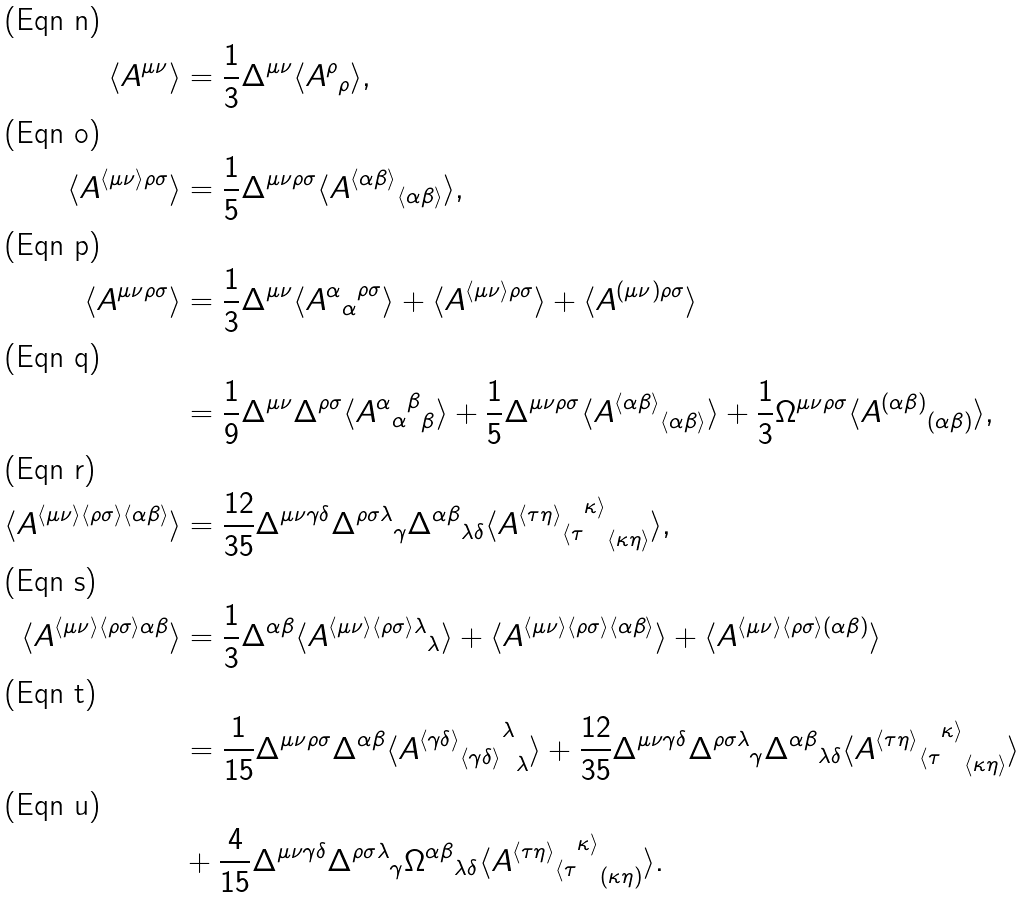Convert formula to latex. <formula><loc_0><loc_0><loc_500><loc_500>\langle A ^ { \mu \nu } \rangle & = \frac { 1 } { 3 } \Delta ^ { \mu \nu } \langle { A ^ { \rho } } _ { \rho } \rangle , \\ \langle A ^ { \langle \mu \nu \rangle \rho \sigma } \rangle & = \frac { 1 } { 5 } \Delta ^ { \mu \nu \rho \sigma } \langle { A ^ { \langle \alpha \beta \rangle } } _ { \langle \alpha \beta \rangle } \rangle , \\ \langle A ^ { \mu \nu \rho \sigma } \rangle & = \frac { 1 } { 3 } \Delta ^ { \mu \nu } \langle { { A ^ { \alpha } } _ { \alpha } } ^ { \rho \sigma } \rangle + \langle A ^ { \langle \mu \nu \rangle \rho \sigma } \rangle + \langle A ^ { ( \mu \nu ) \rho \sigma } \rangle \\ & = \frac { 1 } { 9 } \Delta ^ { \mu \nu } \Delta ^ { \rho \sigma } \langle { { { A ^ { \alpha } } _ { \alpha } } ^ { \beta } } _ { \beta } \rangle + \frac { 1 } { 5 } \Delta ^ { \mu \nu \rho \sigma } \langle { A ^ { \langle \alpha \beta \rangle } } _ { \langle \alpha \beta \rangle } \rangle + \frac { 1 } { 3 } \Omega ^ { \mu \nu \rho \sigma } \langle { A ^ { ( \alpha \beta ) } } _ { ( \alpha \beta ) } \rangle , \\ \langle A ^ { \langle \mu \nu \rangle \langle \rho \sigma \rangle \langle \alpha \beta \rangle } \rangle & = \frac { 1 2 } { 3 5 } \Delta ^ { \mu \nu \gamma \delta } { \Delta ^ { \rho \sigma \lambda } } _ { \gamma } { \Delta ^ { \alpha \beta } } _ { \lambda \delta } \langle { { { A ^ { \langle \tau \eta \rangle } } _ { \langle \tau } } ^ { \kappa \rangle } } _ { \langle \kappa \eta \rangle } \rangle , \\ \langle A ^ { \langle \mu \nu \rangle \langle \rho \sigma \rangle \alpha \beta } \rangle & = \frac { 1 } { 3 } \Delta ^ { \alpha \beta } \langle { A ^ { \langle \mu \nu \rangle \langle \rho \sigma \rangle \lambda } } _ { \lambda } \rangle + \langle A ^ { \langle \mu \nu \rangle \langle \rho \sigma \rangle \langle \alpha \beta \rangle } \rangle + \langle A ^ { \langle \mu \nu \rangle \langle \rho \sigma \rangle ( \alpha \beta ) } \rangle \\ & = \frac { 1 } { 1 5 } \Delta ^ { \mu \nu \rho \sigma } \Delta ^ { \alpha \beta } \langle { { { A ^ { \langle \gamma \delta \rangle } } _ { \langle \gamma \delta \rangle } } ^ { \lambda } } _ { \lambda } \rangle + \frac { 1 2 } { 3 5 } \Delta ^ { \mu \nu \gamma \delta } { \Delta ^ { \rho \sigma \lambda } } _ { \gamma } { \Delta ^ { \alpha \beta } } _ { \lambda \delta } \langle { { { A ^ { \langle \tau \eta \rangle } } _ { \langle \tau } } ^ { \kappa \rangle } } _ { \langle \kappa \eta \rangle } \rangle \\ & + \frac { 4 } { 1 5 } \Delta ^ { \mu \nu \gamma \delta } { \Delta ^ { \rho \sigma \lambda } } _ { \gamma } { \Omega ^ { \alpha \beta } } _ { \lambda \delta } \langle { { { A ^ { \langle \tau \eta \rangle } } _ { \langle \tau } } ^ { \kappa \rangle } } _ { ( \kappa \eta ) } \rangle .</formula> 